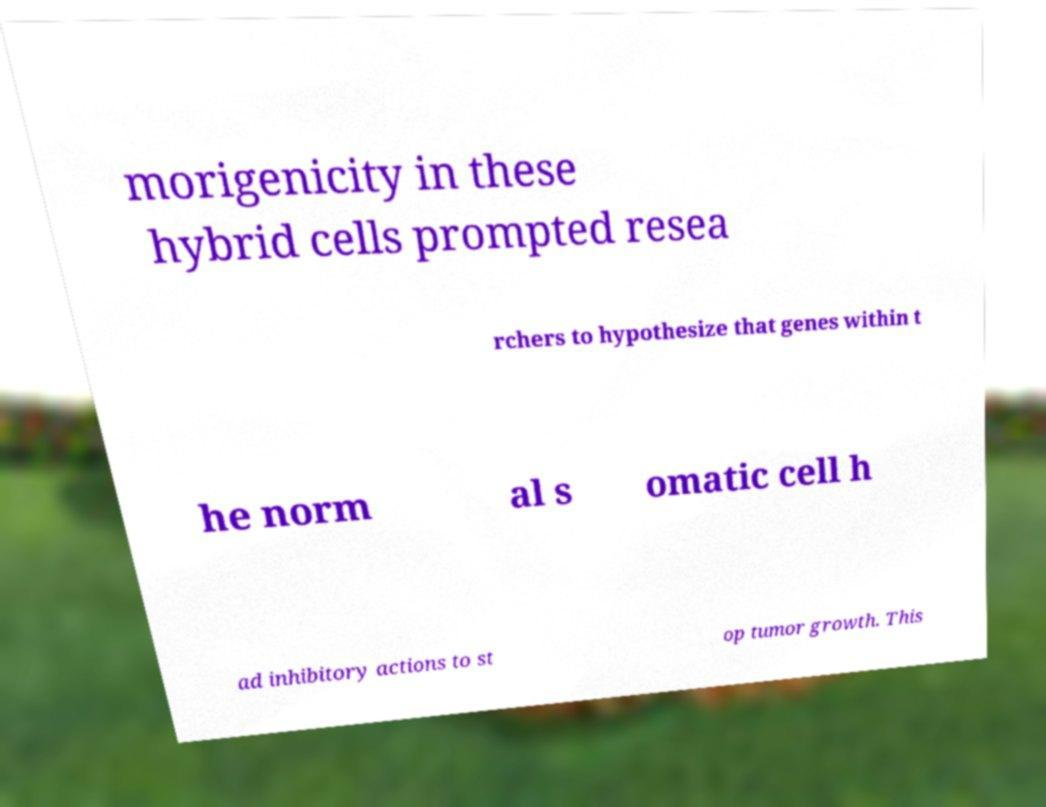What messages or text are displayed in this image? I need them in a readable, typed format. morigenicity in these hybrid cells prompted resea rchers to hypothesize that genes within t he norm al s omatic cell h ad inhibitory actions to st op tumor growth. This 